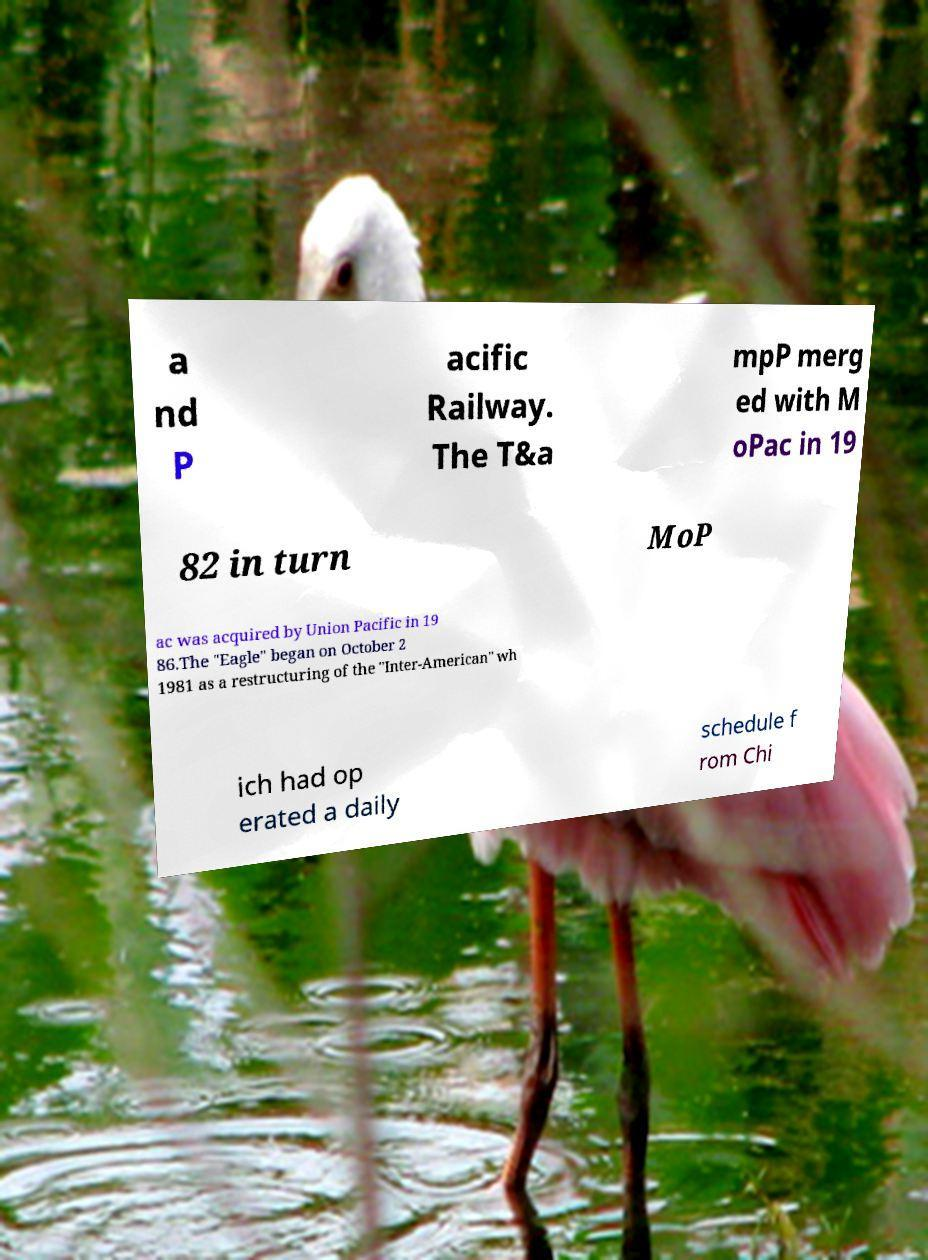Can you read and provide the text displayed in the image?This photo seems to have some interesting text. Can you extract and type it out for me? a nd P acific Railway. The T&a mpP merg ed with M oPac in 19 82 in turn MoP ac was acquired by Union Pacific in 19 86.The "Eagle" began on October 2 1981 as a restructuring of the "Inter-American" wh ich had op erated a daily schedule f rom Chi 